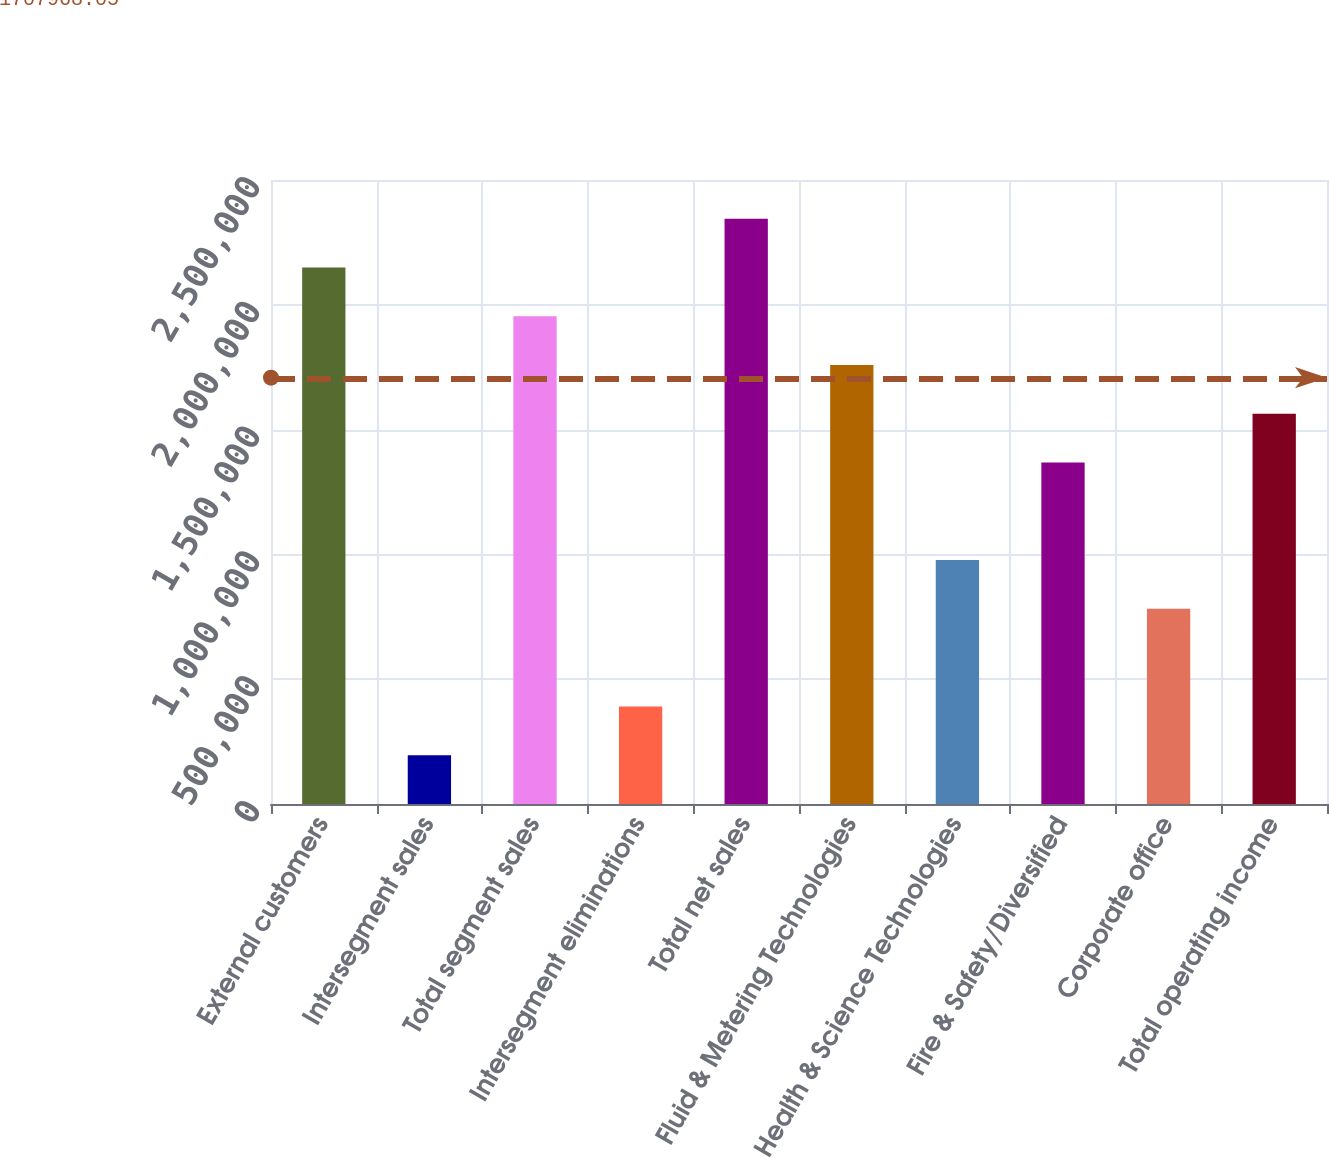Convert chart to OTSL. <chart><loc_0><loc_0><loc_500><loc_500><bar_chart><fcel>External customers<fcel>Intersegment sales<fcel>Total segment sales<fcel>Intersegment eliminations<fcel>Total net sales<fcel>Fluid & Metering Technologies<fcel>Health & Science Technologies<fcel>Fire & Safety/Diversified<fcel>Corporate office<fcel>Total operating income<nl><fcel>2.14966e+06<fcel>195638<fcel>1.95426e+06<fcel>391040<fcel>2.34506e+06<fcel>1.75886e+06<fcel>977247<fcel>1.36805e+06<fcel>781845<fcel>1.56345e+06<nl></chart> 